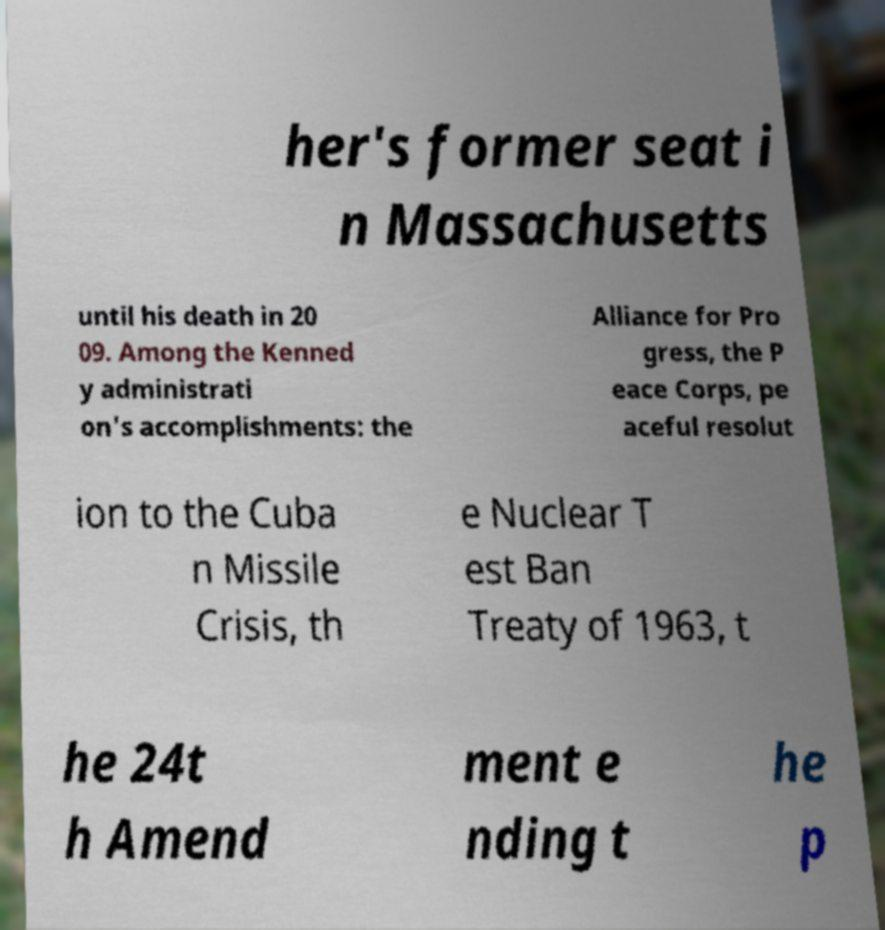Please identify and transcribe the text found in this image. her's former seat i n Massachusetts until his death in 20 09. Among the Kenned y administrati on's accomplishments: the Alliance for Pro gress, the P eace Corps, pe aceful resolut ion to the Cuba n Missile Crisis, th e Nuclear T est Ban Treaty of 1963, t he 24t h Amend ment e nding t he p 